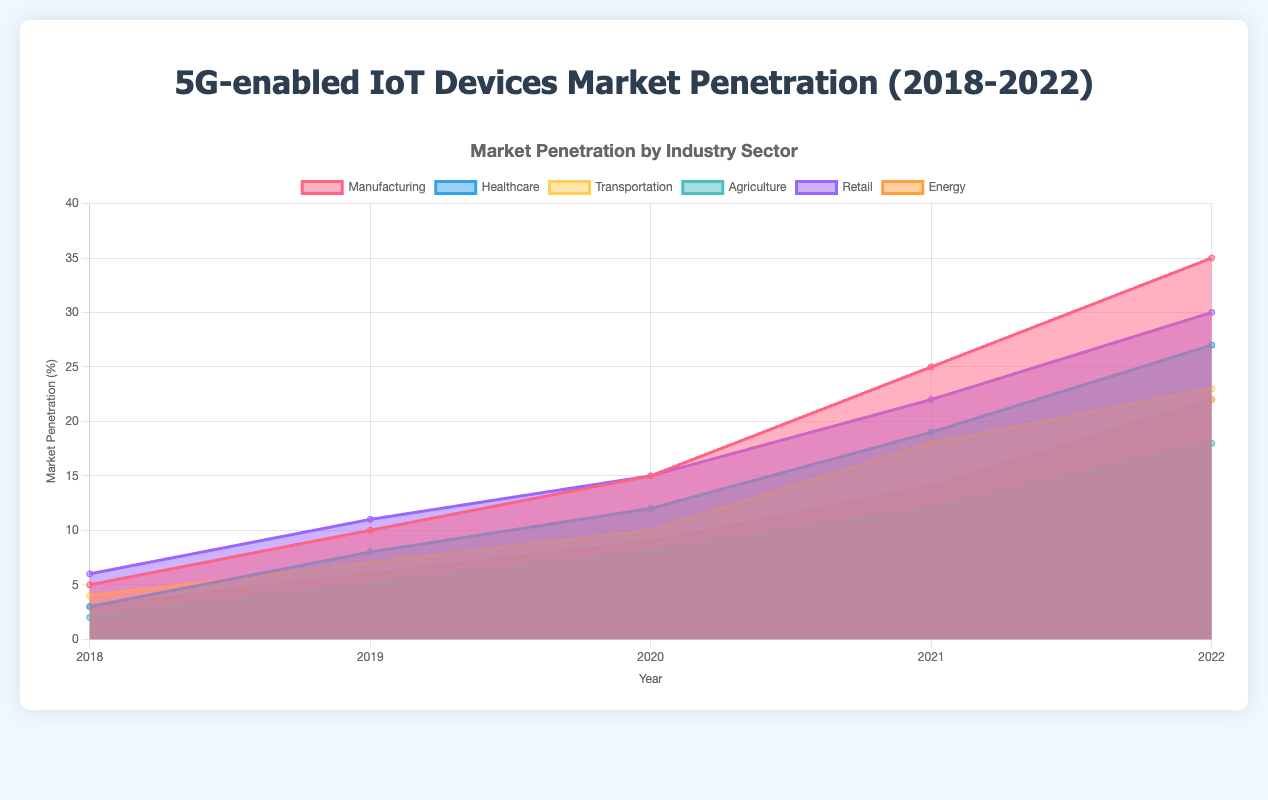What is the title of the chart? The title of the chart is located at the top and reads "5G-enabled IoT Devices Market Penetration (2018-2022)."
Answer: 5G-enabled IoT Devices Market Penetration (2018-2022) Which sector had the highest market penetration in 2022? The chart shows data for different sectors in 2022, and by comparing the values, Retail has the highest value.
Answer: Retail Which sector had the lowest market penetration in 2018? By comparing the values for each sector in 2018, Agriculture has the lowest value.
Answer: Agriculture How did the market penetration in the healthcare sector change from 2018 to 2019? The Healthcare sector increased from 3% in 2018 to 8% in 2019. The increase can be calculated as 8 - 3 = 5%.
Answer: Increased by 5% What was the approximate market penetration for the transportation sector in 2020? Looking at the data points for 2020, the market penetration for the Transportation sector is about 10%.
Answer: 10% Which two sectors had an equal market penetration in 2019? By looking at the values for 2019, both Healthcare and Energy have a market penetration of 6%.
Answer: Energy and Healthcare Among the sectors, which showed the most considerable increase in market penetration from 2018 to 2022? By comparing the values from 2018 to 2022 for each sector, Manufacturing showed the most substantial increase from 5% to 35%, an increase of 30%.
Answer: Manufacturing What is the total market penetration for all sectors in 2022? Adding up the values for 2022 across all sectors: 35 (Manufacturing) + 27 (Healthcare) + 23 (Transportation) + 18 (Agriculture) + 30 (Retail) + 22 (Energy) gives a total of 155.
Answer: 155 How does the market penetration in the Retail sector in 2021 compare to the Energy sector in the same year? In 2021, the Retail sector had a penetration of 22%, while the Energy sector had 14%. Retail is higher than Energy by 8 percentage points.
Answer: Retail is higher by 8 What is the average market penetration for the Agriculture sector over the 5 years? Sum the values over the 5 years: 2 + 5 + 8 + 12 + 18 = 45. Divide by the number of years: 45 / 5 = 9.
Answer: 9 